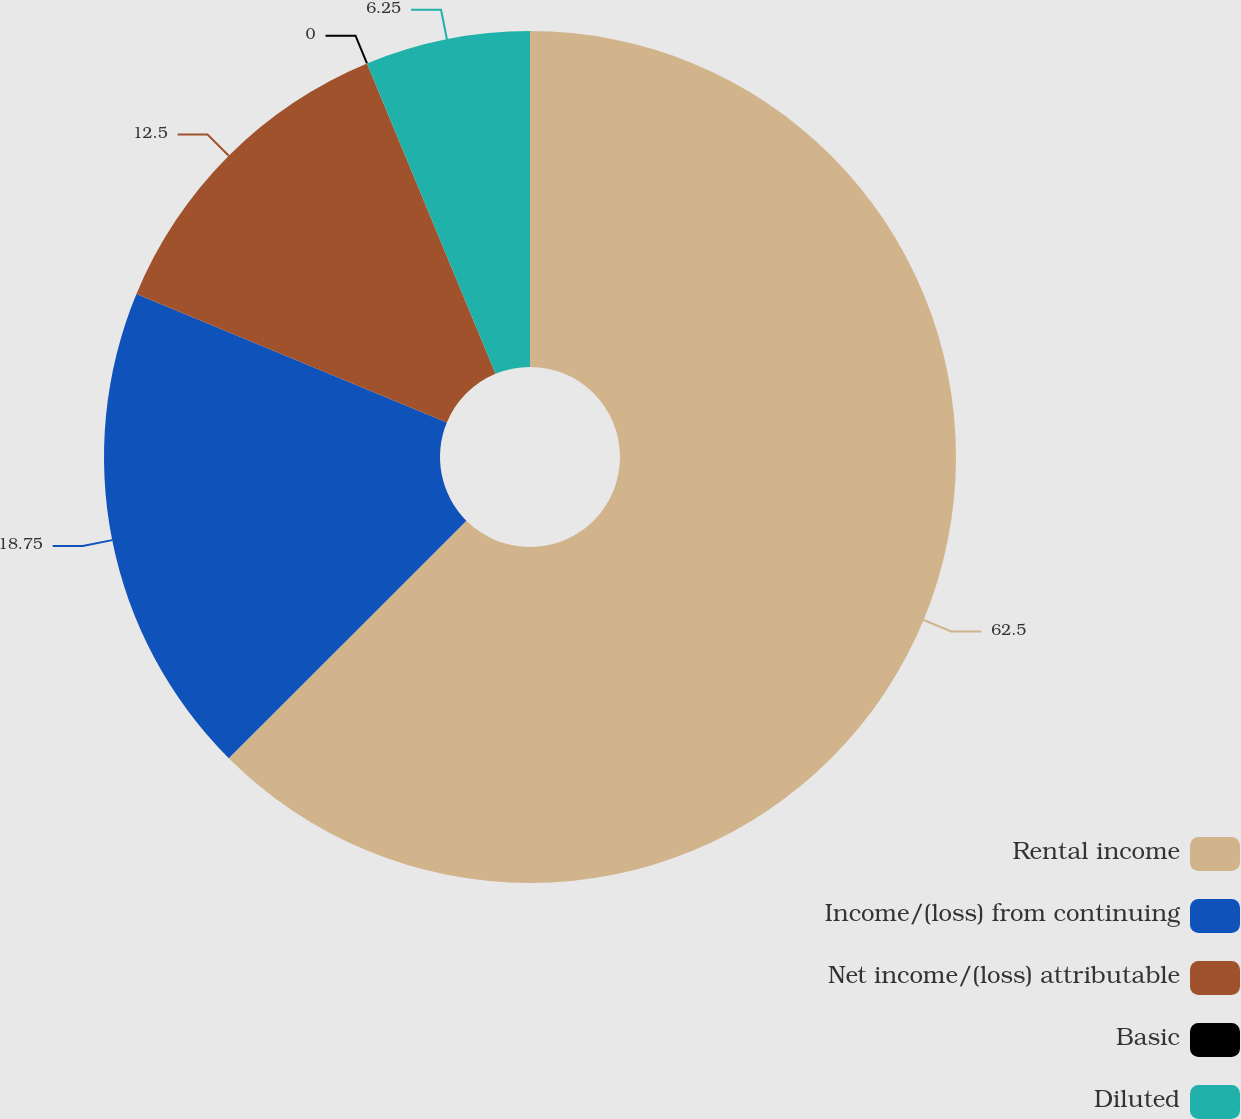<chart> <loc_0><loc_0><loc_500><loc_500><pie_chart><fcel>Rental income<fcel>Income/(loss) from continuing<fcel>Net income/(loss) attributable<fcel>Basic<fcel>Diluted<nl><fcel>62.5%<fcel>18.75%<fcel>12.5%<fcel>0.0%<fcel>6.25%<nl></chart> 